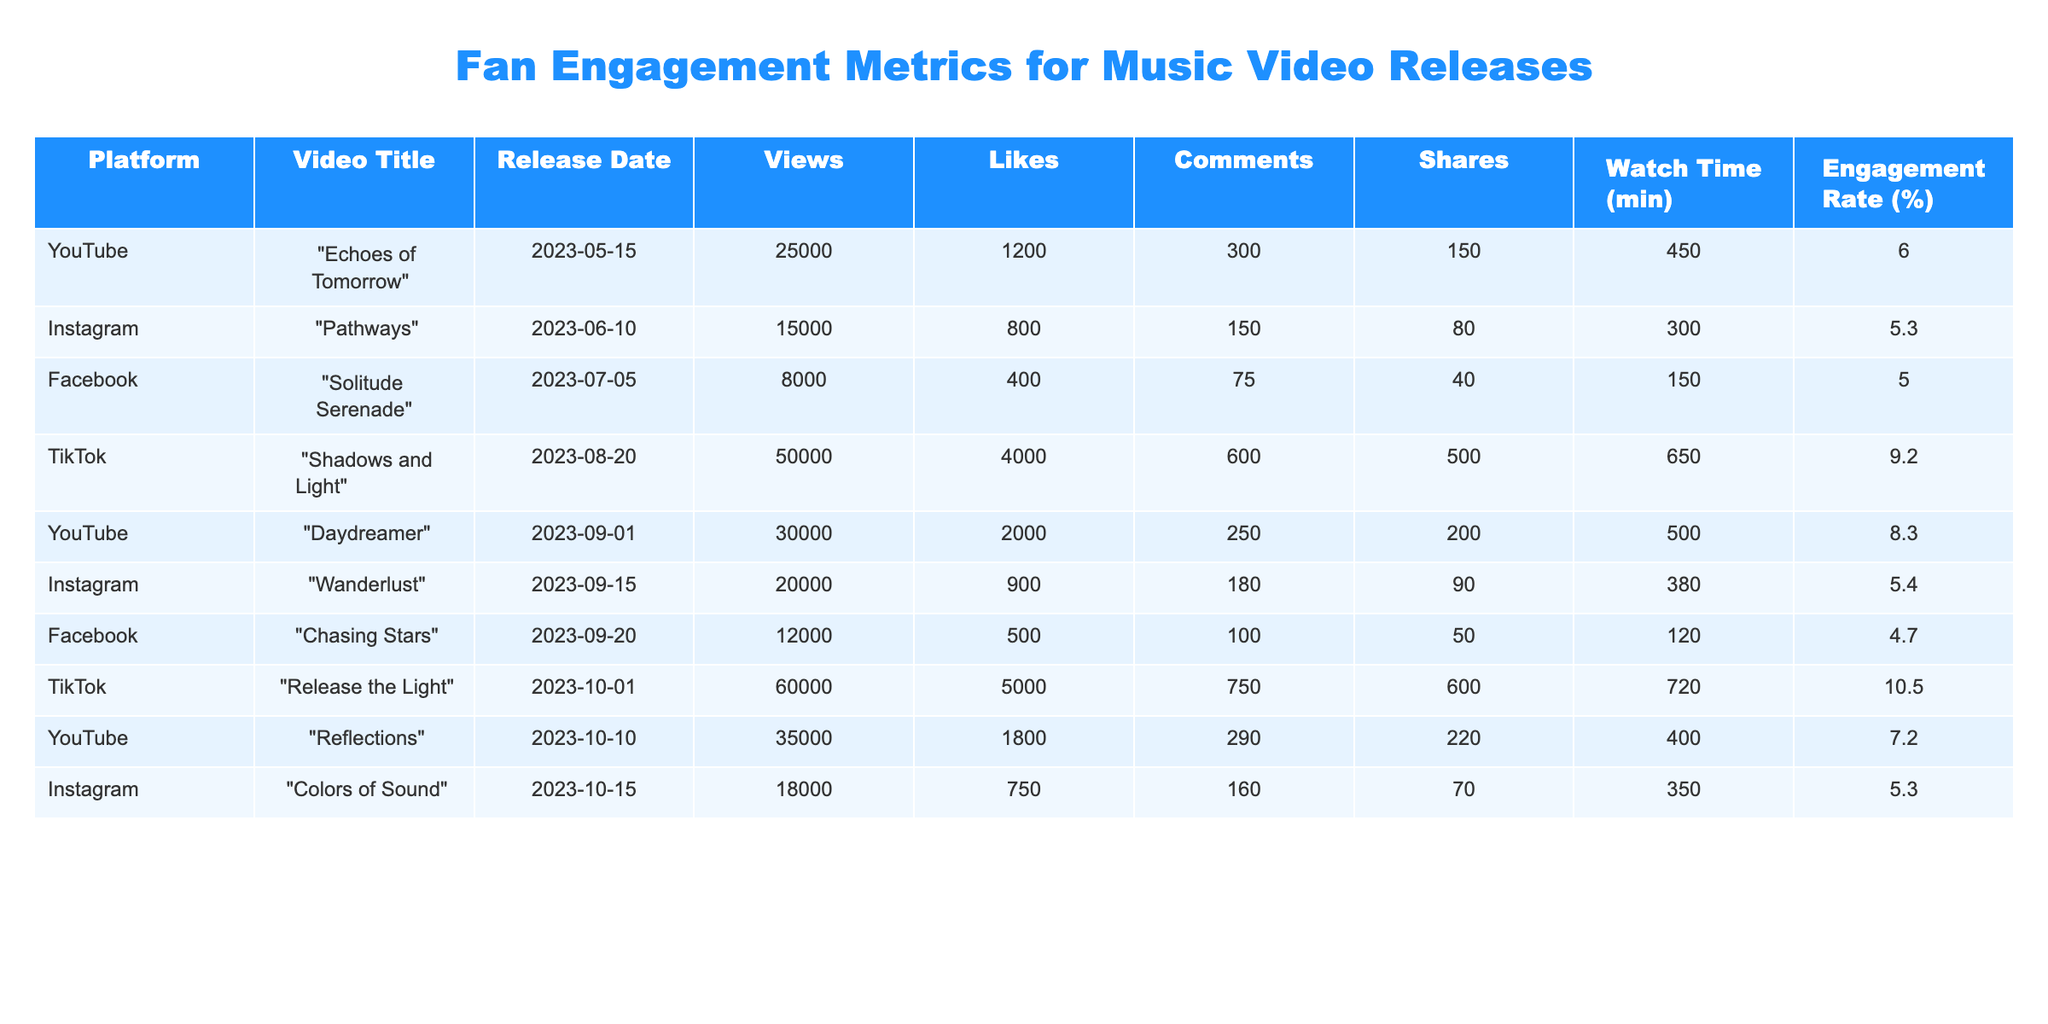What is the total number of views across all music videos? To find the total views, I will add up the views from each video: 25000 + 15000 + 8000 + 50000 + 30000 + 20000 + 12000 + 60000 + 35000 + 18000 = 244000.
Answer: 244000 Which music video received the highest number of likes? The likes for each video are compared: "Echoes of Tomorrow" has 1200, "Pathways" has 800, "Solitude Serenade" has 400, "Shadows and Light" has 4000, "Daydreamer" has 2000, "Wanderlust" has 900, "Chasing Stars" has 500, "Release the Light" has 5000, "Reflections" has 1800, and "Colors of Sound" has 750. "Release the Light" received the highest likes with 5000.
Answer: "Release the Light" What is the average engagement rate for videos released on YouTube? The engagement rates for YouTube videos are: 6.0, 8.3, 7.2. To find the average, I sum them up: (6.0 + 8.3 + 7.2) = 21.5. Then, I divide this sum by the number of YouTube videos, which is 3. So, the average engagement rate is 21.5 / 3 = 7.17.
Answer: 7.2 Is there a video on Instagram that has an engagement rate above 5%? Checking the engagement rates for Instagram: "Pathways" has 5.3% and "Wanderlust" has 5.4%, both of which are above 5%. Therefore, there are Instagram videos with engagement rates above 5%.
Answer: Yes What is the difference in views between the most-viewed video and the least-viewed video? The most-viewed video is "Release the Light" with 60000 views, and the least-viewed video is "Solitude Serenade" with 8000 views. The difference is 60000 - 8000 = 52000.
Answer: 52000 Which platform had the highest average watch time for its music videos? First, I find the average watch time for each platform: YouTube has (450 + 500 + 400) / 3 = 450, Instagram has (300 + 380) / 2 = 340, Facebook has (150 + 120) / 2 = 135, and TikTok has (650 + 720) / 2 = 685. The highest average watch time is on TikTok with 685 minutes.
Answer: TikTok How many shares did the video "Chasing Stars" receive compared to "Pathways"? "Chasing Stars" received 50 shares whereas "Pathways" received 80 shares. The difference in shares is 80 - 50 = 30.
Answer: 30 What percentage of likes did "Shadows and Light" receive compared to its views? "Shadows and Light" has 50000 views and 4000 likes. To calculate the like percentage: (4000 / 50000) * 100 = 8%.
Answer: 8% Which video had the lowest engagement rate and what was it? For engagement rates: "Chasing Stars" has the lowest at 4.7%. Comparing all, we find that this is the lowest.
Answer: 4.7% 